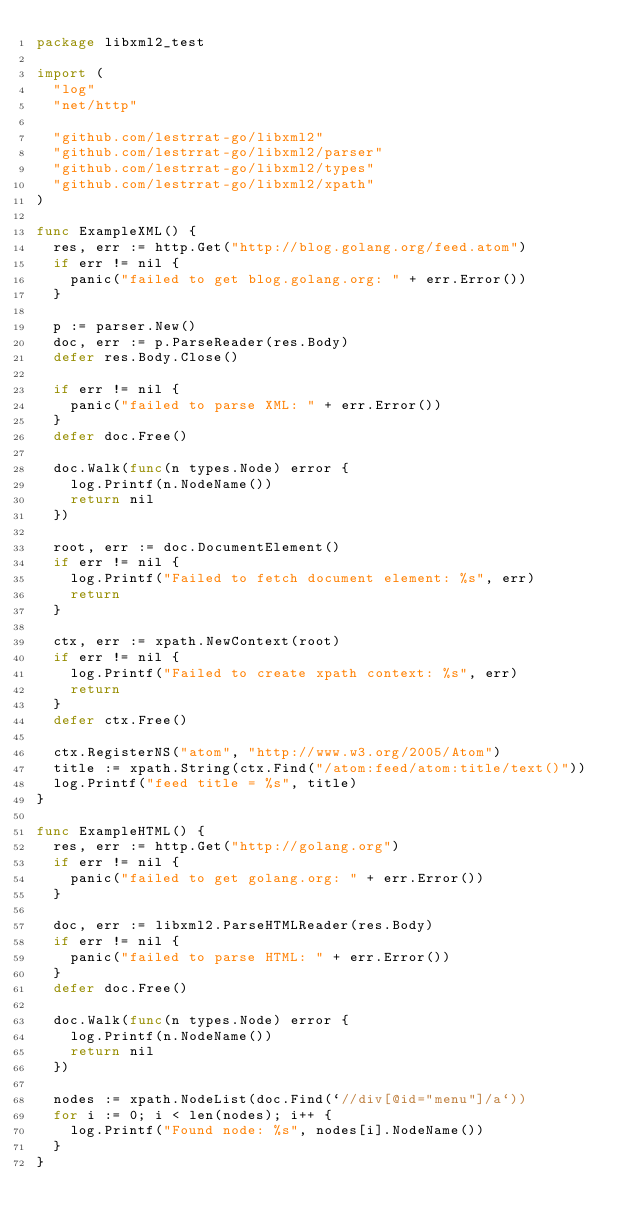Convert code to text. <code><loc_0><loc_0><loc_500><loc_500><_Go_>package libxml2_test

import (
	"log"
	"net/http"

	"github.com/lestrrat-go/libxml2"
	"github.com/lestrrat-go/libxml2/parser"
	"github.com/lestrrat-go/libxml2/types"
	"github.com/lestrrat-go/libxml2/xpath"
)

func ExampleXML() {
	res, err := http.Get("http://blog.golang.org/feed.atom")
	if err != nil {
		panic("failed to get blog.golang.org: " + err.Error())
	}

	p := parser.New()
	doc, err := p.ParseReader(res.Body)
	defer res.Body.Close()

	if err != nil {
		panic("failed to parse XML: " + err.Error())
	}
	defer doc.Free()

	doc.Walk(func(n types.Node) error {
		log.Printf(n.NodeName())
		return nil
	})

	root, err := doc.DocumentElement()
	if err != nil {
		log.Printf("Failed to fetch document element: %s", err)
		return
	}

	ctx, err := xpath.NewContext(root)
	if err != nil {
		log.Printf("Failed to create xpath context: %s", err)
		return
	}
	defer ctx.Free()

	ctx.RegisterNS("atom", "http://www.w3.org/2005/Atom")
	title := xpath.String(ctx.Find("/atom:feed/atom:title/text()"))
	log.Printf("feed title = %s", title)
}

func ExampleHTML() {
	res, err := http.Get("http://golang.org")
	if err != nil {
		panic("failed to get golang.org: " + err.Error())
	}

	doc, err := libxml2.ParseHTMLReader(res.Body)
	if err != nil {
		panic("failed to parse HTML: " + err.Error())
	}
	defer doc.Free()

	doc.Walk(func(n types.Node) error {
		log.Printf(n.NodeName())
		return nil
	})

	nodes := xpath.NodeList(doc.Find(`//div[@id="menu"]/a`))
	for i := 0; i < len(nodes); i++ {
		log.Printf("Found node: %s", nodes[i].NodeName())
	}
}
</code> 